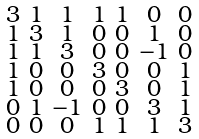<formula> <loc_0><loc_0><loc_500><loc_500>\begin{smallmatrix} 3 & 1 & 1 & 1 & 1 & 0 & 0 \\ 1 & 3 & 1 & 0 & 0 & 1 & 0 \\ 1 & 1 & 3 & 0 & 0 & - 1 & 0 \\ 1 & 0 & 0 & 3 & 0 & 0 & 1 \\ 1 & 0 & 0 & 0 & 3 & 0 & 1 \\ 0 & 1 & - 1 & 0 & 0 & 3 & 1 \\ 0 & 0 & 0 & 1 & 1 & 1 & 3 \end{smallmatrix}</formula> 